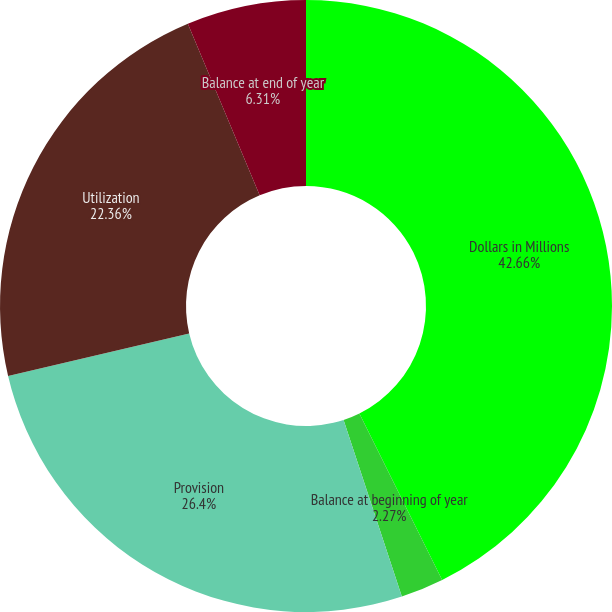<chart> <loc_0><loc_0><loc_500><loc_500><pie_chart><fcel>Dollars in Millions<fcel>Balance at beginning of year<fcel>Provision<fcel>Utilization<fcel>Balance at end of year<nl><fcel>42.66%<fcel>2.27%<fcel>26.4%<fcel>22.36%<fcel>6.31%<nl></chart> 